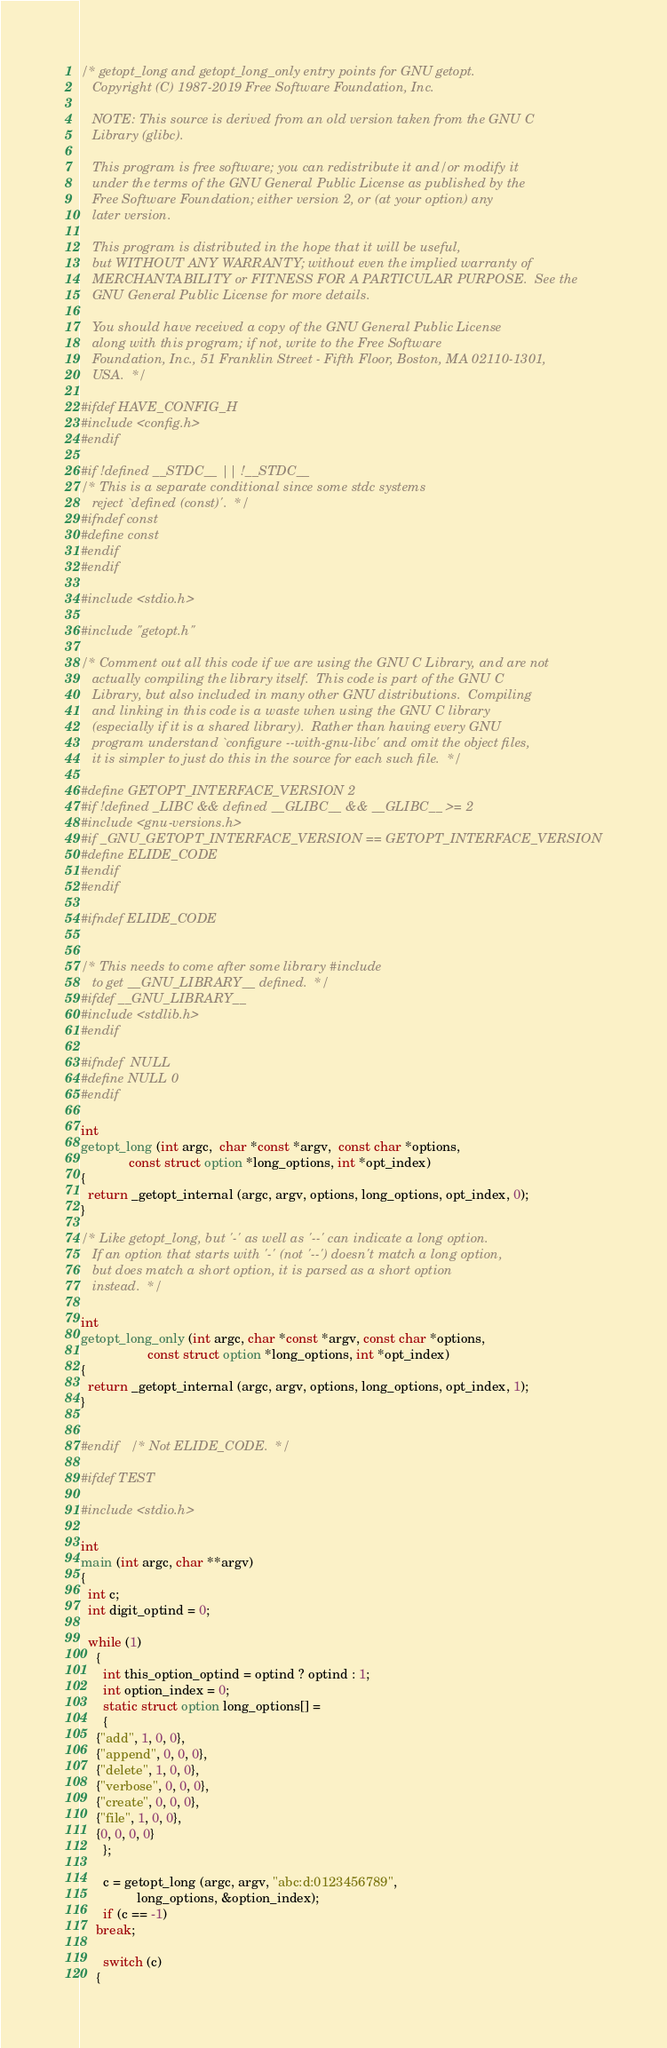<code> <loc_0><loc_0><loc_500><loc_500><_C_>/* getopt_long and getopt_long_only entry points for GNU getopt.
   Copyright (C) 1987-2019 Free Software Foundation, Inc.

   NOTE: This source is derived from an old version taken from the GNU C
   Library (glibc).

   This program is free software; you can redistribute it and/or modify it
   under the terms of the GNU General Public License as published by the
   Free Software Foundation; either version 2, or (at your option) any
   later version.

   This program is distributed in the hope that it will be useful,
   but WITHOUT ANY WARRANTY; without even the implied warranty of
   MERCHANTABILITY or FITNESS FOR A PARTICULAR PURPOSE.  See the
   GNU General Public License for more details.

   You should have received a copy of the GNU General Public License
   along with this program; if not, write to the Free Software
   Foundation, Inc., 51 Franklin Street - Fifth Floor, Boston, MA 02110-1301,
   USA.  */

#ifdef HAVE_CONFIG_H
#include <config.h>
#endif

#if !defined __STDC__ || !__STDC__
/* This is a separate conditional since some stdc systems
   reject `defined (const)'.  */
#ifndef const
#define const
#endif
#endif

#include <stdio.h>

#include "getopt.h"

/* Comment out all this code if we are using the GNU C Library, and are not
   actually compiling the library itself.  This code is part of the GNU C
   Library, but also included in many other GNU distributions.  Compiling
   and linking in this code is a waste when using the GNU C library
   (especially if it is a shared library).  Rather than having every GNU
   program understand `configure --with-gnu-libc' and omit the object files,
   it is simpler to just do this in the source for each such file.  */

#define GETOPT_INTERFACE_VERSION 2
#if !defined _LIBC && defined __GLIBC__ && __GLIBC__ >= 2
#include <gnu-versions.h>
#if _GNU_GETOPT_INTERFACE_VERSION == GETOPT_INTERFACE_VERSION
#define ELIDE_CODE
#endif
#endif

#ifndef ELIDE_CODE


/* This needs to come after some library #include
   to get __GNU_LIBRARY__ defined.  */
#ifdef __GNU_LIBRARY__
#include <stdlib.h>
#endif

#ifndef	NULL
#define NULL 0
#endif

int
getopt_long (int argc,  char *const *argv,  const char *options,
             const struct option *long_options, int *opt_index)
{
  return _getopt_internal (argc, argv, options, long_options, opt_index, 0);
}

/* Like getopt_long, but '-' as well as '--' can indicate a long option.
   If an option that starts with '-' (not '--') doesn't match a long option,
   but does match a short option, it is parsed as a short option
   instead.  */

int
getopt_long_only (int argc, char *const *argv, const char *options,
                  const struct option *long_options, int *opt_index)
{
  return _getopt_internal (argc, argv, options, long_options, opt_index, 1);
}


#endif	/* Not ELIDE_CODE.  */

#ifdef TEST

#include <stdio.h>

int
main (int argc, char **argv)
{
  int c;
  int digit_optind = 0;

  while (1)
    {
      int this_option_optind = optind ? optind : 1;
      int option_index = 0;
      static struct option long_options[] =
      {
	{"add", 1, 0, 0},
	{"append", 0, 0, 0},
	{"delete", 1, 0, 0},
	{"verbose", 0, 0, 0},
	{"create", 0, 0, 0},
	{"file", 1, 0, 0},
	{0, 0, 0, 0}
      };

      c = getopt_long (argc, argv, "abc:d:0123456789",
		       long_options, &option_index);
      if (c == -1)
	break;

      switch (c)
	{</code> 